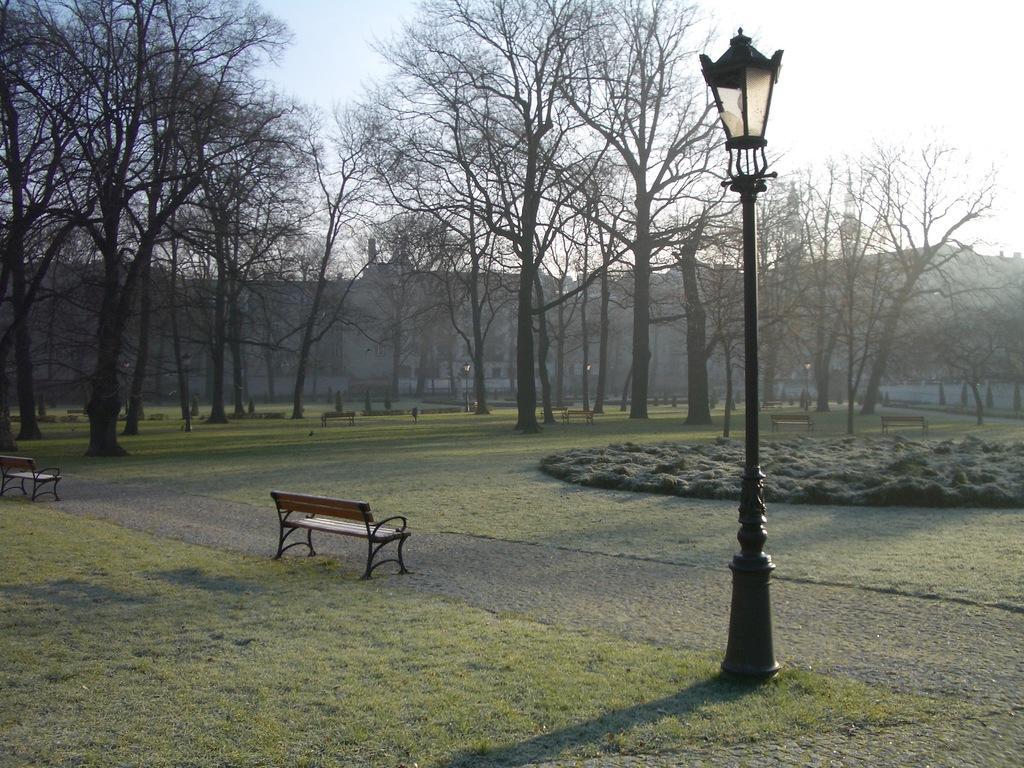Can you describe this image briefly? In the center of the image there are benches. On the right there is a pole. In the background there are trees, buildings and sky. 